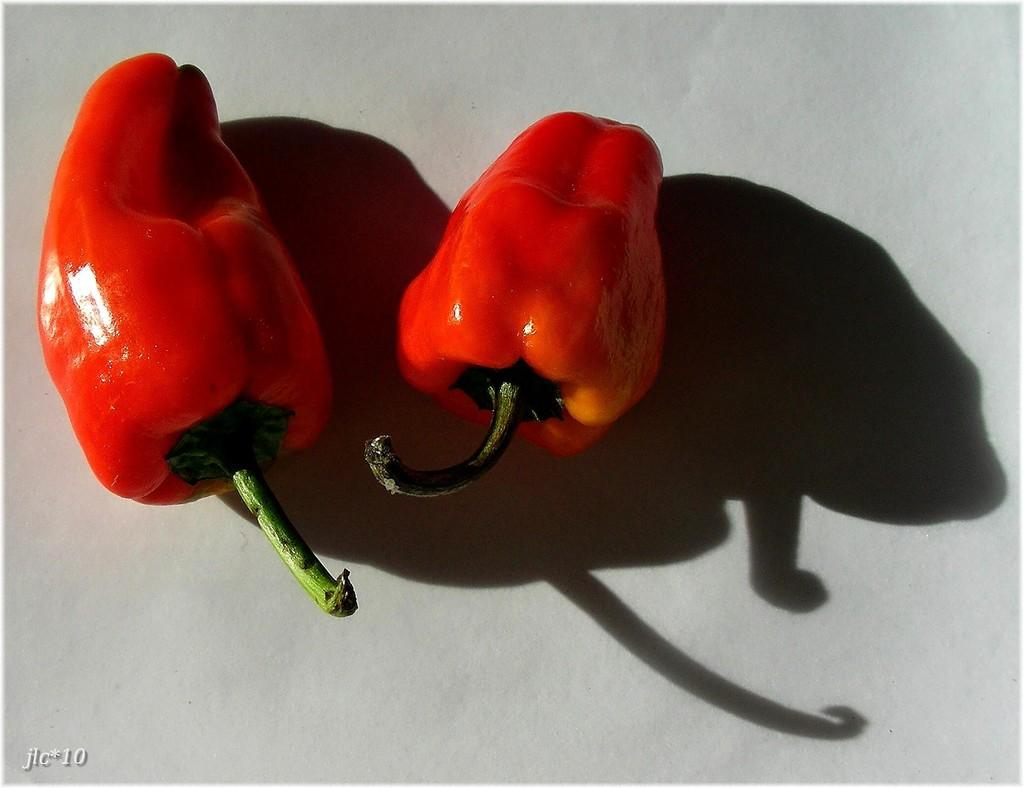What type of vegetables are present in the image? There are two red capsicums in the image. What color are the capsicums? The capsicums are red. On what object are the capsicums placed? The red capsicums are on a white object. What type of club can be seen in the image? There is no club present in the image; it features two red capsicums on a white object. Is there any rain visible in the image? There is no rain present in the image. 